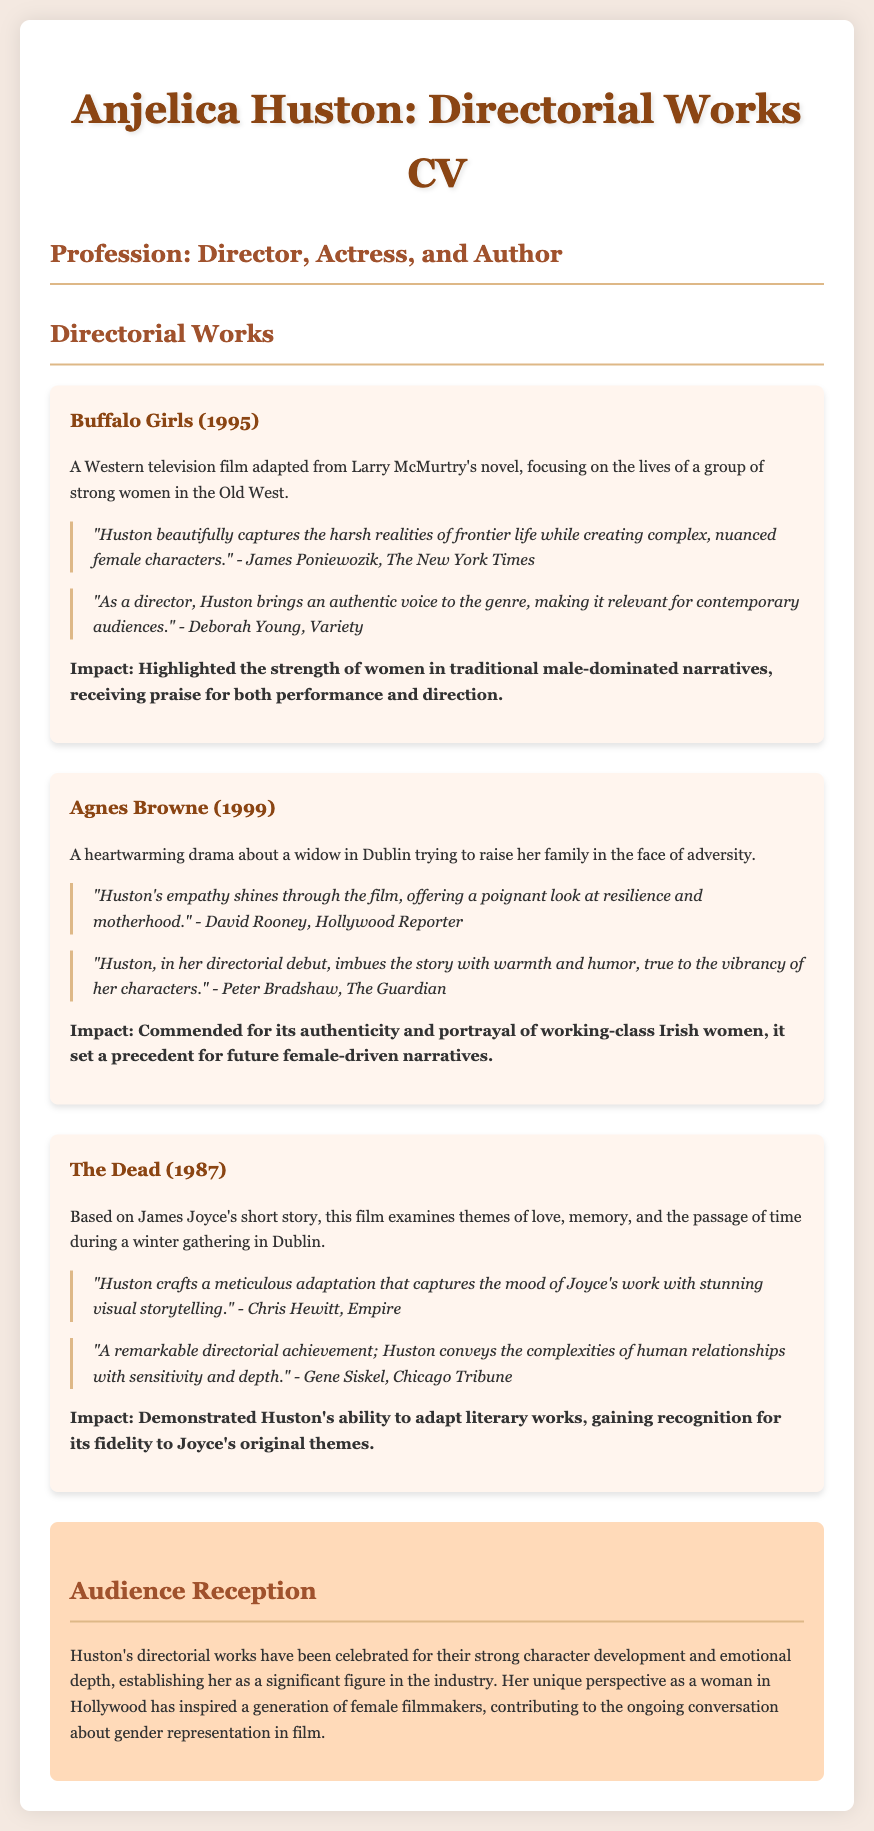What is Anjelica Huston's profession? The document states that Anjelica Huston's profession is Director, Actress, and Author.
Answer: Director, Actress, and Author What year was "Buffalo Girls" released? The release year for "Buffalo Girls" is provided in the document as 1995.
Answer: 1995 Who wrote the novel "Buffalo Girls" is based on? The document indicates that "Buffalo Girls" is adapted from a novel by Larry McMurtry.
Answer: Larry McMurtry What is the primary theme of "The Dead"? The primary theme of "The Dead," as described in the document, includes love, memory, and the passage of time.
Answer: Love, memory, and the passage of time Which film marked Anjelica Huston’s directorial debut? The document specifies that "Agnes Browne" is Huston's directorial debut.
Answer: Agnes Browne What impact did "Agnes Browne" have? The document notes that "Agnes Browne" was commended for its authenticity and portrayal of working-class Irish women.
Answer: Authenticity and portrayal of working-class Irish women How do audiences generally receive Huston's directorial works? The document states that Huston's directorial works have been celebrated for strong character development and emotional depth.
Answer: Strong character development and emotional depth Which publication reviewed "Buffalo Girls"? The critiques for "Buffalo Girls" include a review from The New York Times.
Answer: The New York Times What is a key characteristic of Huston's direction highlighted in the critiques? The critiques emphasize that Huston creates complex, nuanced female characters in her films.
Answer: Complex, nuanced female characters 